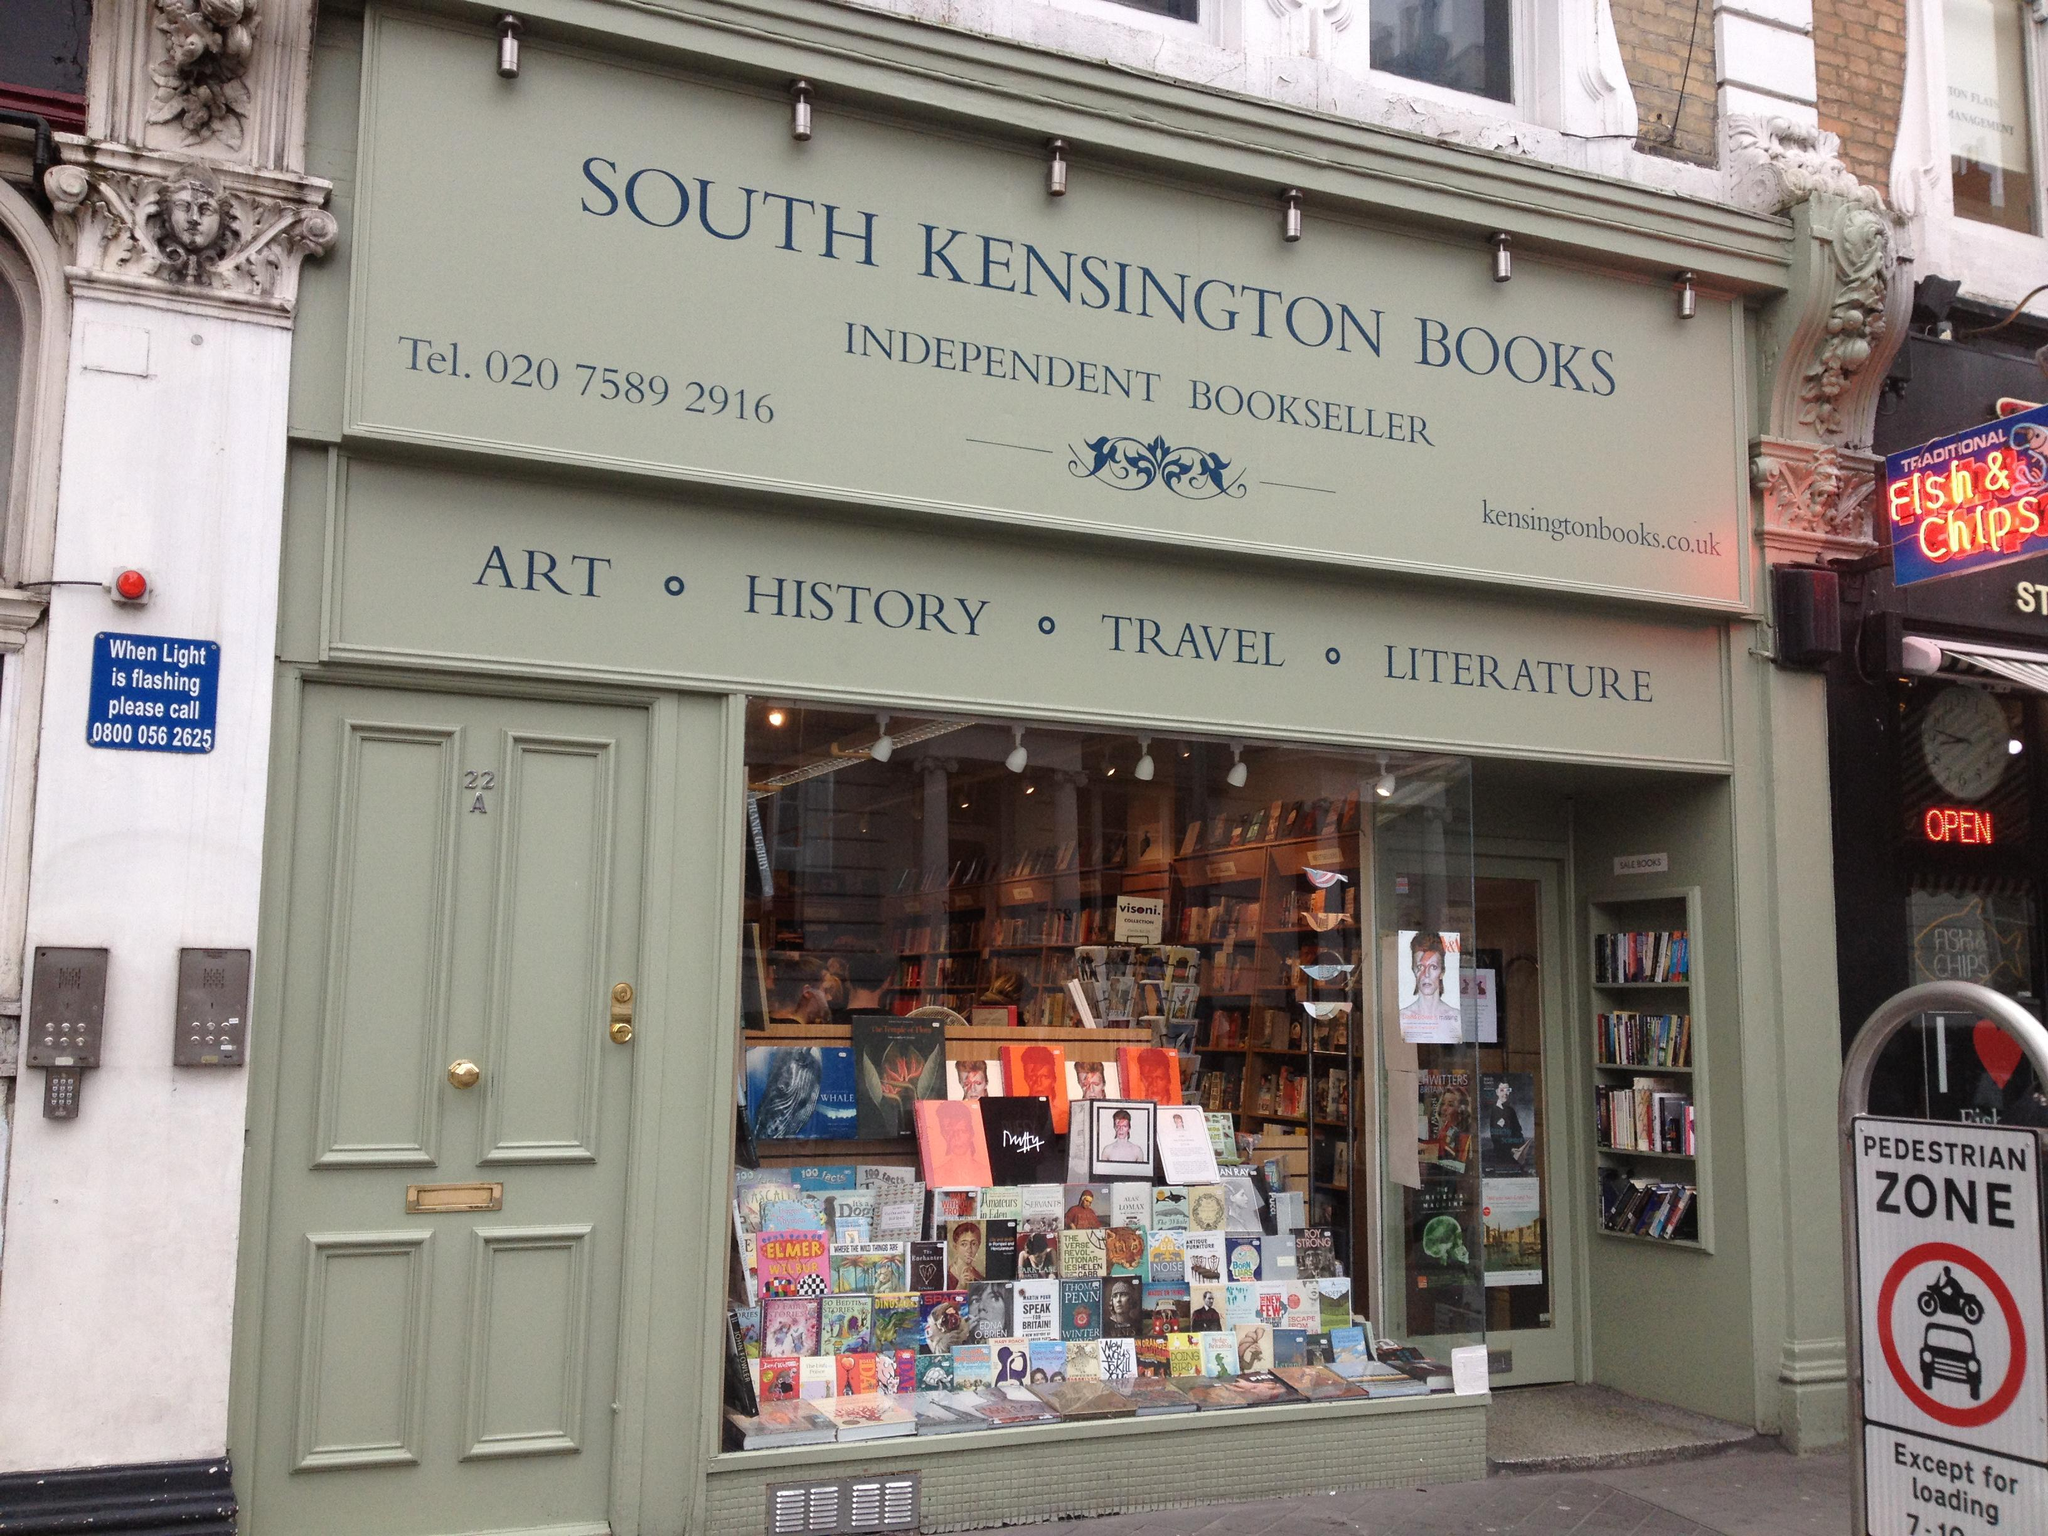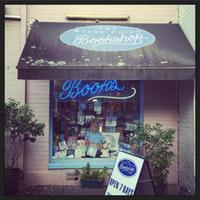The first image is the image on the left, the second image is the image on the right. Given the left and right images, does the statement "The bookshop in the right image has an informational fold out sign out front." hold true? Answer yes or no. Yes. The first image is the image on the left, the second image is the image on the right. Considering the images on both sides, is "In at least one image there is a single book display in the window with at least one neon sign hanging about the books." valid? Answer yes or no. Yes. 